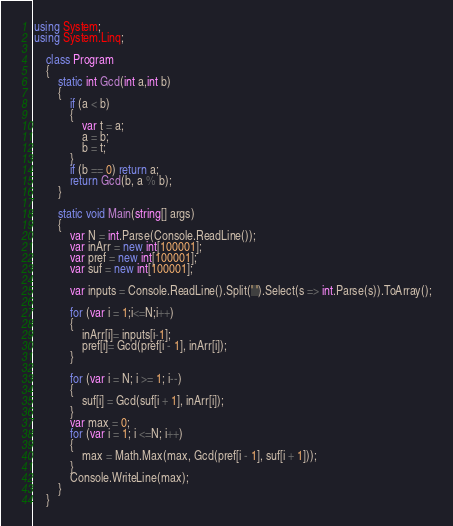Convert code to text. <code><loc_0><loc_0><loc_500><loc_500><_C#_>using System;
using System.Linq;

    class Program
    {
        static int Gcd(int a,int b)
        {
            if (a < b)
            {
                var t = a;
                a = b;
                b = t;
            }
            if (b == 0) return a;
            return Gcd(b, a % b);
        }

        static void Main(string[] args)
        {
            var N = int.Parse(Console.ReadLine());
            var inArr = new int[100001];
            var pref = new int[100001];
            var suf = new int[100001];

            var inputs = Console.ReadLine().Split(' ').Select(s => int.Parse(s)).ToArray();

            for (var i = 1;i<=N;i++)
            {
                inArr[i]= inputs[i-1];
                pref[i]= Gcd(pref[i - 1], inArr[i]);
            }

            for (var i = N; i >= 1; i--)
            {
                suf[i] = Gcd(suf[i + 1], inArr[i]);
            }
            var max = 0;
            for (var i = 1; i <=N; i++)
            {
                max = Math.Max(max, Gcd(pref[i - 1], suf[i + 1]));
            }
            Console.WriteLine(max);
        }
    }</code> 